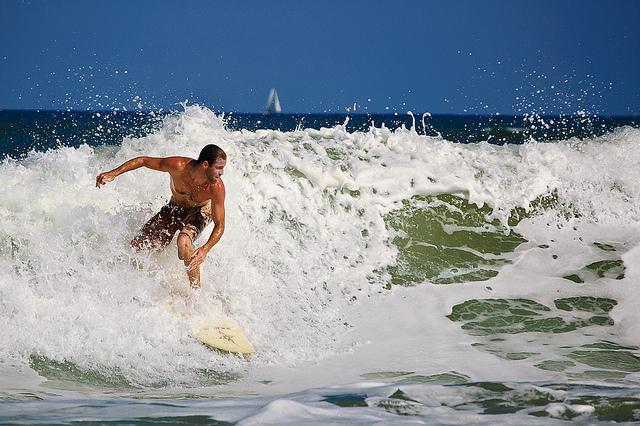Is there a shark in the water?
Keep it brief. No. How many boats are in the background?
Write a very short answer. 1. What is the man doing?
Concise answer only. Surfing. 